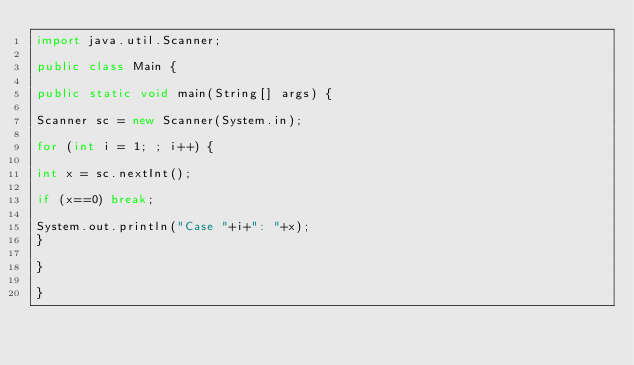Convert code to text. <code><loc_0><loc_0><loc_500><loc_500><_Java_>import java.util.Scanner;

public class Main {

public static void main(String[] args) {

Scanner sc = new Scanner(System.in);

for (int i = 1; ; i++) {

int x = sc.nextInt();

if (x==0) break;

System.out.println("Case "+i+": "+x);
}

}

}</code> 